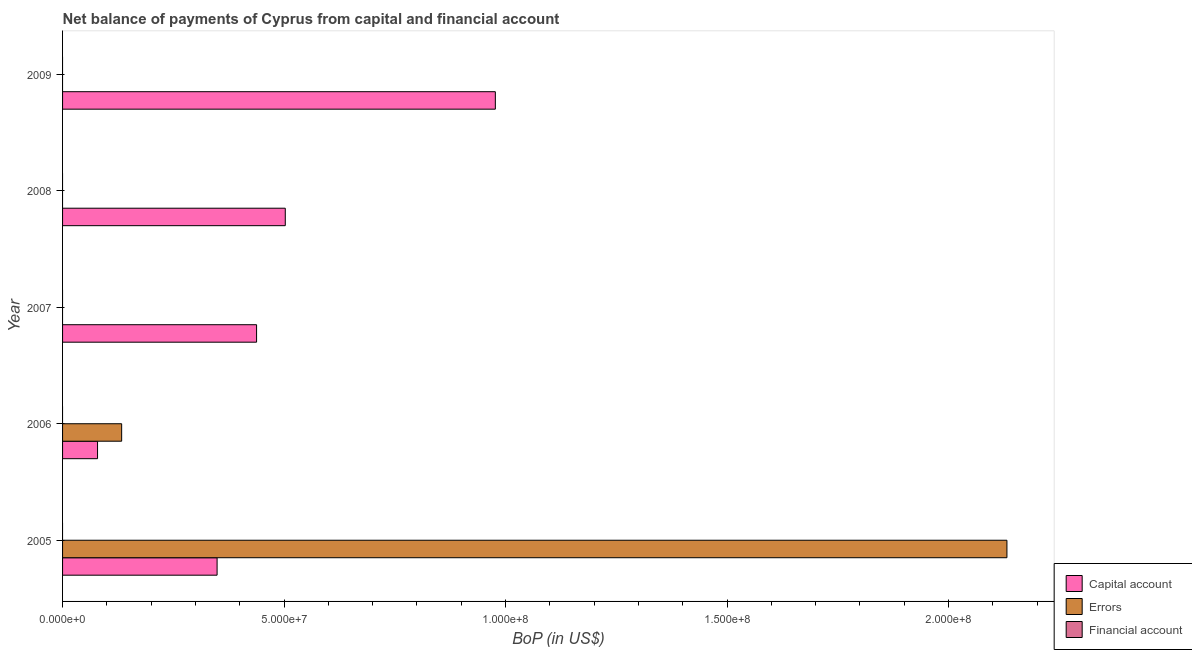How many different coloured bars are there?
Give a very brief answer. 2. Are the number of bars per tick equal to the number of legend labels?
Ensure brevity in your answer.  No. Are the number of bars on each tick of the Y-axis equal?
Your response must be concise. No. How many bars are there on the 5th tick from the bottom?
Keep it short and to the point. 1. In how many cases, is the number of bars for a given year not equal to the number of legend labels?
Your answer should be very brief. 5. Across all years, what is the maximum amount of errors?
Provide a short and direct response. 2.13e+08. In which year was the amount of net capital account maximum?
Your response must be concise. 2009. What is the total amount of financial account in the graph?
Give a very brief answer. 0. What is the difference between the amount of net capital account in 2005 and that in 2008?
Offer a terse response. -1.54e+07. What is the difference between the amount of net capital account in 2006 and the amount of financial account in 2008?
Give a very brief answer. 7.90e+06. In how many years, is the amount of net capital account greater than 90000000 US$?
Make the answer very short. 1. What is the ratio of the amount of net capital account in 2007 to that in 2009?
Give a very brief answer. 0.45. Is the amount of net capital account in 2005 less than that in 2009?
Make the answer very short. Yes. Is the difference between the amount of net capital account in 2005 and 2006 greater than the difference between the amount of errors in 2005 and 2006?
Offer a terse response. No. What is the difference between the highest and the second highest amount of net capital account?
Your response must be concise. 4.74e+07. What is the difference between the highest and the lowest amount of errors?
Give a very brief answer. 2.13e+08. In how many years, is the amount of financial account greater than the average amount of financial account taken over all years?
Give a very brief answer. 0. Is the sum of the amount of net capital account in 2006 and 2008 greater than the maximum amount of errors across all years?
Your answer should be very brief. No. Is it the case that in every year, the sum of the amount of net capital account and amount of errors is greater than the amount of financial account?
Give a very brief answer. Yes. How many years are there in the graph?
Give a very brief answer. 5. What is the difference between two consecutive major ticks on the X-axis?
Provide a succinct answer. 5.00e+07. Are the values on the major ticks of X-axis written in scientific E-notation?
Provide a succinct answer. Yes. Does the graph contain any zero values?
Your response must be concise. Yes. Does the graph contain grids?
Give a very brief answer. No. How many legend labels are there?
Your answer should be very brief. 3. What is the title of the graph?
Offer a very short reply. Net balance of payments of Cyprus from capital and financial account. What is the label or title of the X-axis?
Ensure brevity in your answer.  BoP (in US$). What is the label or title of the Y-axis?
Provide a short and direct response. Year. What is the BoP (in US$) in Capital account in 2005?
Your response must be concise. 3.49e+07. What is the BoP (in US$) in Errors in 2005?
Your response must be concise. 2.13e+08. What is the BoP (in US$) in Capital account in 2006?
Provide a short and direct response. 7.90e+06. What is the BoP (in US$) in Errors in 2006?
Provide a short and direct response. 1.33e+07. What is the BoP (in US$) of Capital account in 2007?
Keep it short and to the point. 4.38e+07. What is the BoP (in US$) of Financial account in 2007?
Offer a terse response. 0. What is the BoP (in US$) in Capital account in 2008?
Offer a terse response. 5.03e+07. What is the BoP (in US$) in Capital account in 2009?
Offer a terse response. 9.77e+07. What is the BoP (in US$) of Errors in 2009?
Provide a short and direct response. 0. Across all years, what is the maximum BoP (in US$) in Capital account?
Offer a very short reply. 9.77e+07. Across all years, what is the maximum BoP (in US$) of Errors?
Your answer should be very brief. 2.13e+08. Across all years, what is the minimum BoP (in US$) in Capital account?
Give a very brief answer. 7.90e+06. Across all years, what is the minimum BoP (in US$) of Errors?
Give a very brief answer. 0. What is the total BoP (in US$) in Capital account in the graph?
Provide a succinct answer. 2.35e+08. What is the total BoP (in US$) in Errors in the graph?
Offer a terse response. 2.27e+08. What is the difference between the BoP (in US$) in Capital account in 2005 and that in 2006?
Ensure brevity in your answer.  2.70e+07. What is the difference between the BoP (in US$) in Errors in 2005 and that in 2006?
Your response must be concise. 2.00e+08. What is the difference between the BoP (in US$) of Capital account in 2005 and that in 2007?
Give a very brief answer. -8.91e+06. What is the difference between the BoP (in US$) in Capital account in 2005 and that in 2008?
Ensure brevity in your answer.  -1.54e+07. What is the difference between the BoP (in US$) in Capital account in 2005 and that in 2009?
Make the answer very short. -6.28e+07. What is the difference between the BoP (in US$) of Capital account in 2006 and that in 2007?
Ensure brevity in your answer.  -3.59e+07. What is the difference between the BoP (in US$) in Capital account in 2006 and that in 2008?
Provide a succinct answer. -4.24e+07. What is the difference between the BoP (in US$) of Capital account in 2006 and that in 2009?
Your answer should be compact. -8.98e+07. What is the difference between the BoP (in US$) in Capital account in 2007 and that in 2008?
Keep it short and to the point. -6.48e+06. What is the difference between the BoP (in US$) of Capital account in 2007 and that in 2009?
Offer a terse response. -5.39e+07. What is the difference between the BoP (in US$) of Capital account in 2008 and that in 2009?
Keep it short and to the point. -4.74e+07. What is the difference between the BoP (in US$) of Capital account in 2005 and the BoP (in US$) of Errors in 2006?
Offer a very short reply. 2.15e+07. What is the average BoP (in US$) of Capital account per year?
Your answer should be very brief. 4.69e+07. What is the average BoP (in US$) in Errors per year?
Make the answer very short. 4.53e+07. In the year 2005, what is the difference between the BoP (in US$) of Capital account and BoP (in US$) of Errors?
Your answer should be very brief. -1.78e+08. In the year 2006, what is the difference between the BoP (in US$) of Capital account and BoP (in US$) of Errors?
Your answer should be compact. -5.44e+06. What is the ratio of the BoP (in US$) of Capital account in 2005 to that in 2006?
Your answer should be very brief. 4.42. What is the ratio of the BoP (in US$) of Errors in 2005 to that in 2006?
Offer a terse response. 15.98. What is the ratio of the BoP (in US$) in Capital account in 2005 to that in 2007?
Ensure brevity in your answer.  0.8. What is the ratio of the BoP (in US$) in Capital account in 2005 to that in 2008?
Offer a terse response. 0.69. What is the ratio of the BoP (in US$) in Capital account in 2005 to that in 2009?
Your answer should be compact. 0.36. What is the ratio of the BoP (in US$) of Capital account in 2006 to that in 2007?
Offer a very short reply. 0.18. What is the ratio of the BoP (in US$) in Capital account in 2006 to that in 2008?
Make the answer very short. 0.16. What is the ratio of the BoP (in US$) of Capital account in 2006 to that in 2009?
Make the answer very short. 0.08. What is the ratio of the BoP (in US$) in Capital account in 2007 to that in 2008?
Your answer should be very brief. 0.87. What is the ratio of the BoP (in US$) of Capital account in 2007 to that in 2009?
Keep it short and to the point. 0.45. What is the ratio of the BoP (in US$) in Capital account in 2008 to that in 2009?
Make the answer very short. 0.51. What is the difference between the highest and the second highest BoP (in US$) in Capital account?
Keep it short and to the point. 4.74e+07. What is the difference between the highest and the lowest BoP (in US$) of Capital account?
Provide a succinct answer. 8.98e+07. What is the difference between the highest and the lowest BoP (in US$) in Errors?
Offer a very short reply. 2.13e+08. 